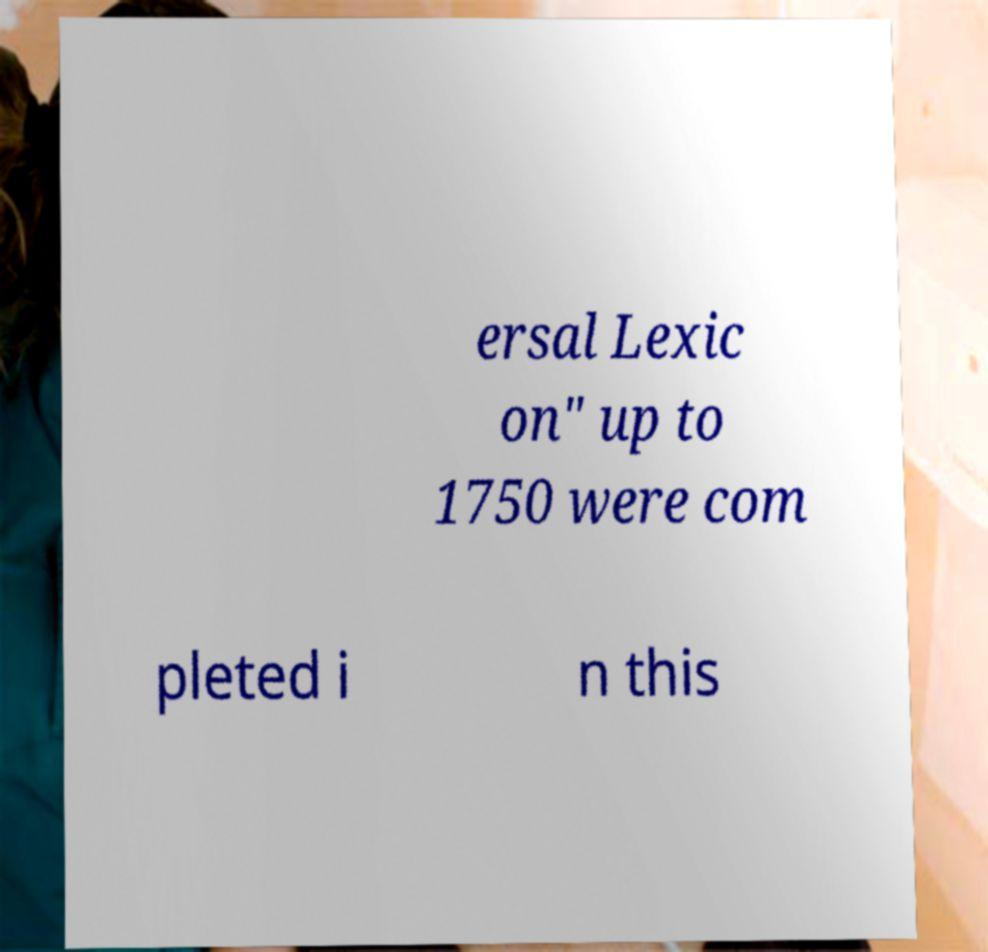Could you extract and type out the text from this image? ersal Lexic on" up to 1750 were com pleted i n this 